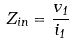Convert formula to latex. <formula><loc_0><loc_0><loc_500><loc_500>Z _ { i n } = \frac { v _ { 1 } } { i _ { 1 } }</formula> 